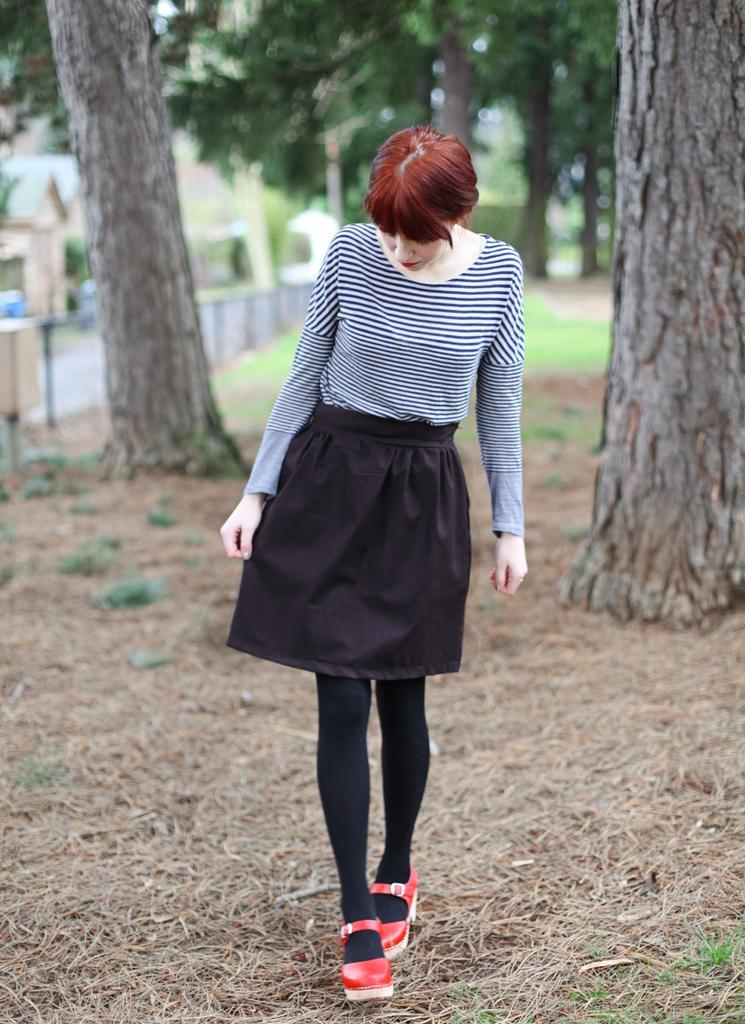Please provide a concise description of this image. In this image a beautiful woman is walking, she wore black and white top, black color short, socks and red color shoes. At the bottom there is the dried grass. Behind her there are trees, on the left side it looks like a road and there are houses. 